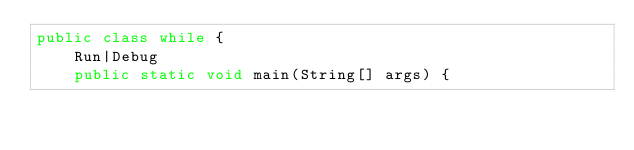<code> <loc_0><loc_0><loc_500><loc_500><_Java_>public class while {
    Run|Debug
    public static void main(String[] args) { 
</code> 